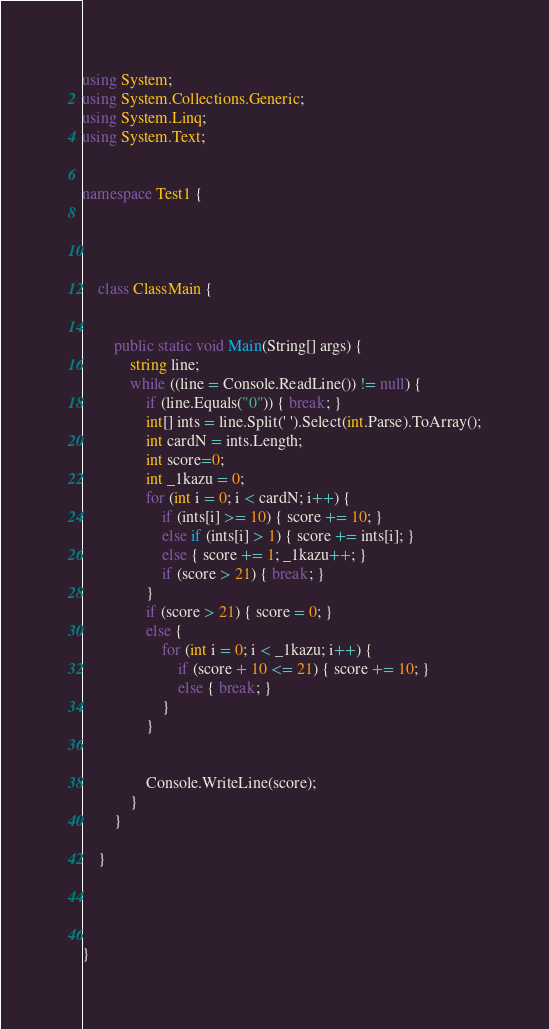Convert code to text. <code><loc_0><loc_0><loc_500><loc_500><_C#_>using System;
using System.Collections.Generic;
using System.Linq;
using System.Text;


namespace Test1 {

    


    class ClassMain {


        public static void Main(String[] args) {
            string line;
            while ((line = Console.ReadLine()) != null) {
                if (line.Equals("0")) { break; }
                int[] ints = line.Split(' ').Select(int.Parse).ToArray();
                int cardN = ints.Length;
                int score=0;
                int _1kazu = 0;
                for (int i = 0; i < cardN; i++) {
                    if (ints[i] >= 10) { score += 10; }
                    else if (ints[i] > 1) { score += ints[i]; }
                    else { score += 1; _1kazu++; }
                    if (score > 21) { break; }
                }
                if (score > 21) { score = 0; }
                else {
                    for (int i = 0; i < _1kazu; i++) {
                        if (score + 10 <= 21) { score += 10; }
                        else { break; }
                    }
                }

                
                Console.WriteLine(score);
            }
        }
    
    }



    
}</code> 